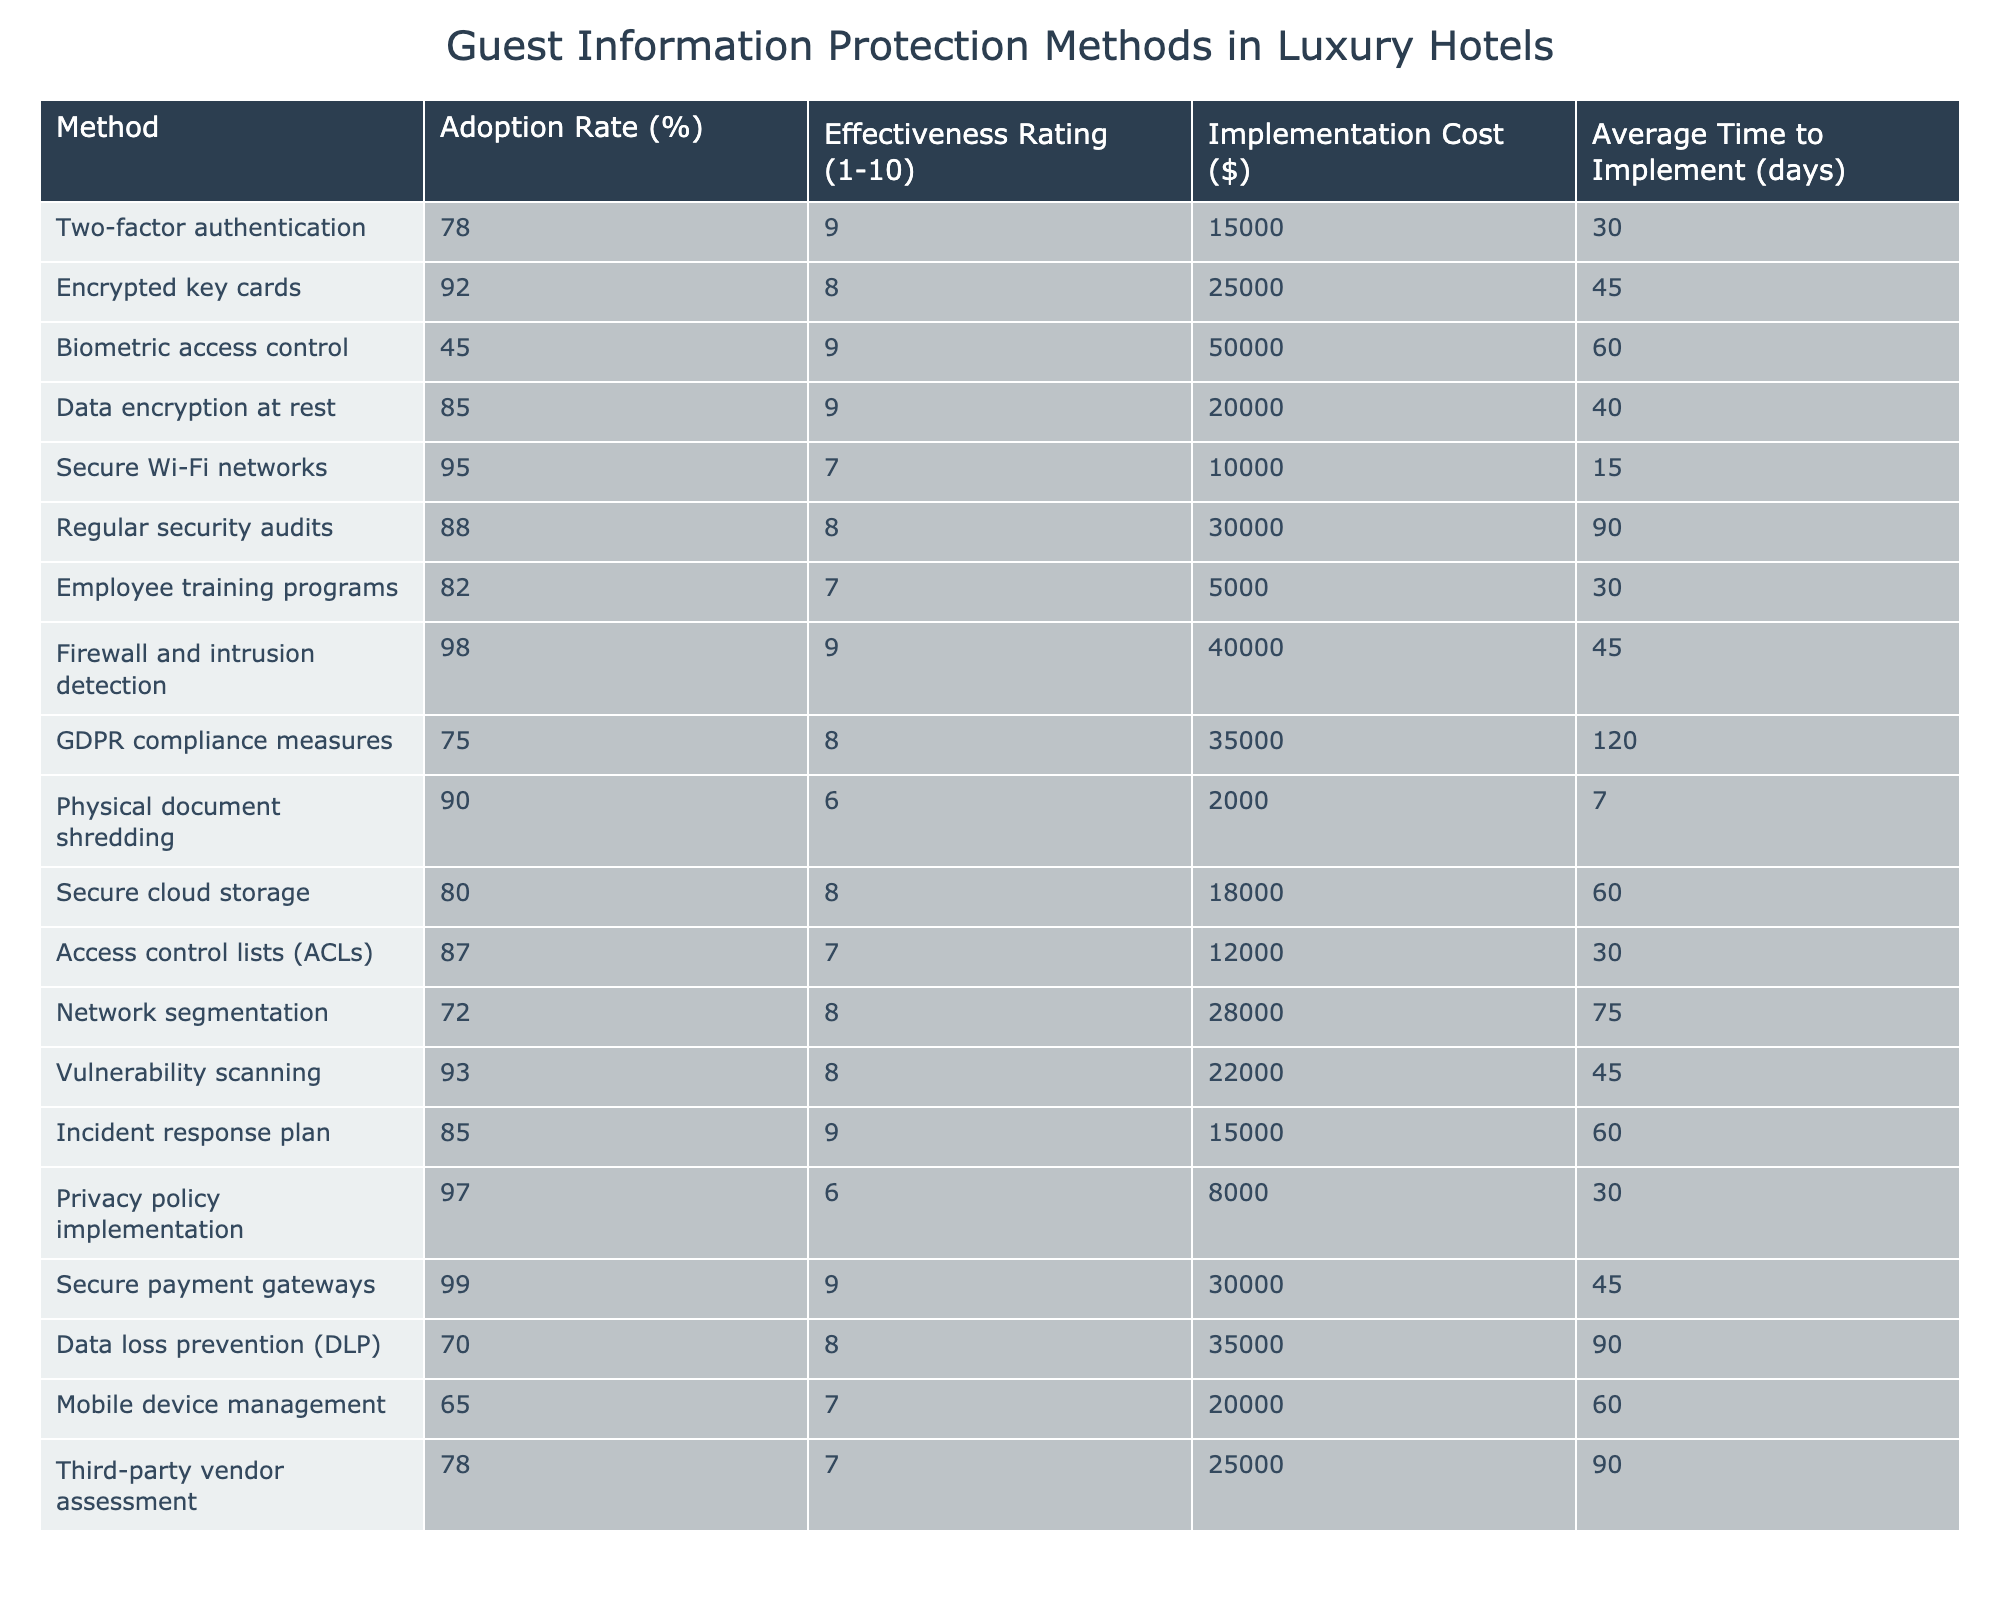What's the adoption rate of biometric access control? The table indicates the adoption rate is explicitly included in the data for biometric access control, which shows 45%.
Answer: 45% What is the effectiveness rating of regular security audits? The effectiveness rating for regular security audits is found in the table, which states it is rated 8 out of 10.
Answer: 8 Which protection method has the highest adoption rate? By reviewing the adoption rates in the table, secure payment gateways have the highest rate at 99%.
Answer: 99% What is the average time to implement the most adopted protection methods (above 90%)? We identify the methods with adoption rates greater than 90%: encrypted key cards (45 days), secure Wi-Fi networks (15 days), firewall and intrusion detection (45 days), and secure payment gateways (45 days). The average is (45 + 15 + 45 + 45) / 4 = 37.5 days.
Answer: 37.5 days Is the implementation cost for privacy policy implementation greater than that for employee training programs? From the table, the implementation cost for privacy policy implementation is $8,000 while employee training programs cost $5,000. Since $8,000 is greater than $5,000, the answer is yes.
Answer: Yes What is the difference in effectiveness ratings between network segmentation and data encryption at rest? The effectiveness rating for network segmentation is 8, while for data encryption at rest it is 9. The difference is calculated as 9 - 8 = 1.
Answer: 1 Which method has the lowest adoption rate, and what is that rate? Looking through the table, mobile device management has the lowest adoption rate at 65%.
Answer: 65% Calculate the total implementation cost of the top three methods by effectiveness rating. The top three methods by effectiveness ratings are: biometric access control ($50,000), two-factor authentication ($15,000), and data encryption at rest ($20,000). The total cost is $50,000 + $15,000 + $20,000 = $85,000.
Answer: $85,000 Are vulnerability scanning and GDPR compliance measures equally effective? Referencing the effectiveness ratings in the table, vulnerability scanning has a rating of 8, while GDPR compliance measures rate 8 as well, so they are indeed equally effective.
Answer: Yes Which method requires the longest average time to implement, and how long is that? Checking the average implementation times in the table, regular security audits require the longest time at 90 days.
Answer: 90 days 